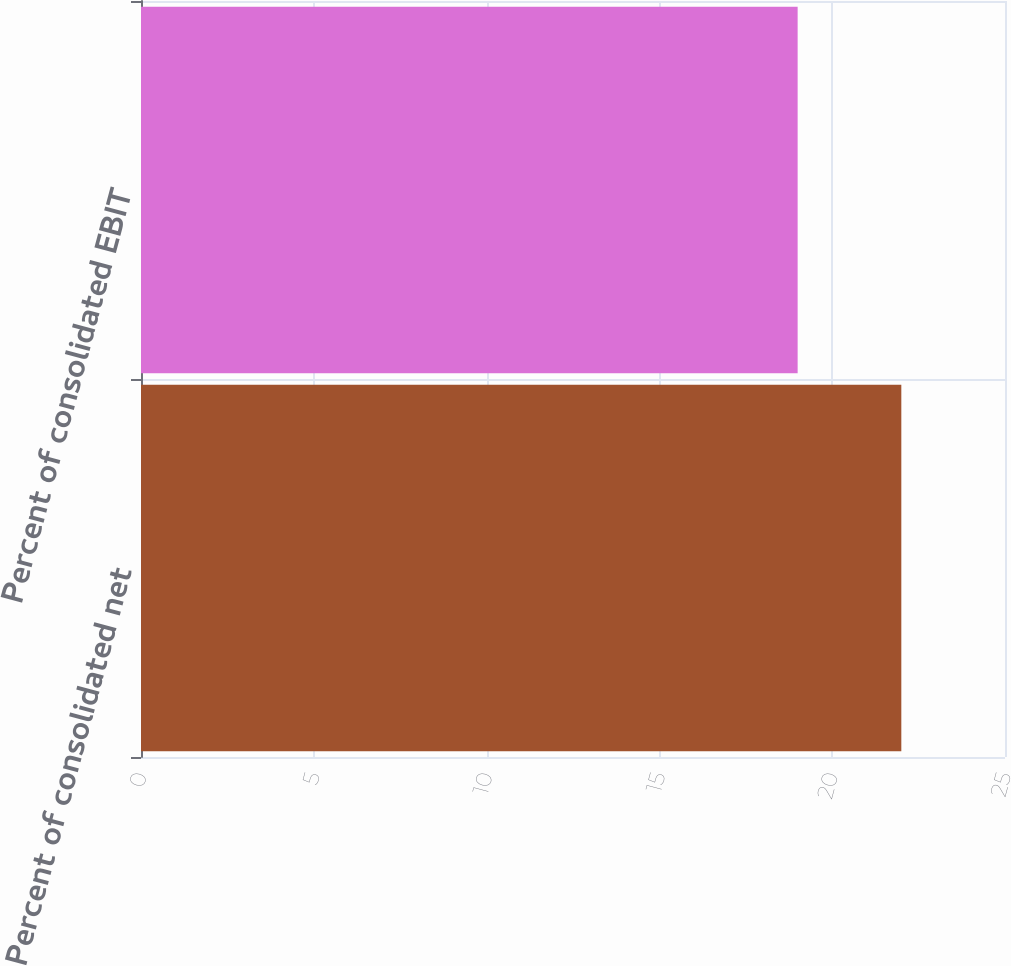Convert chart. <chart><loc_0><loc_0><loc_500><loc_500><bar_chart><fcel>Percent of consolidated net<fcel>Percent of consolidated EBIT<nl><fcel>22<fcel>19<nl></chart> 